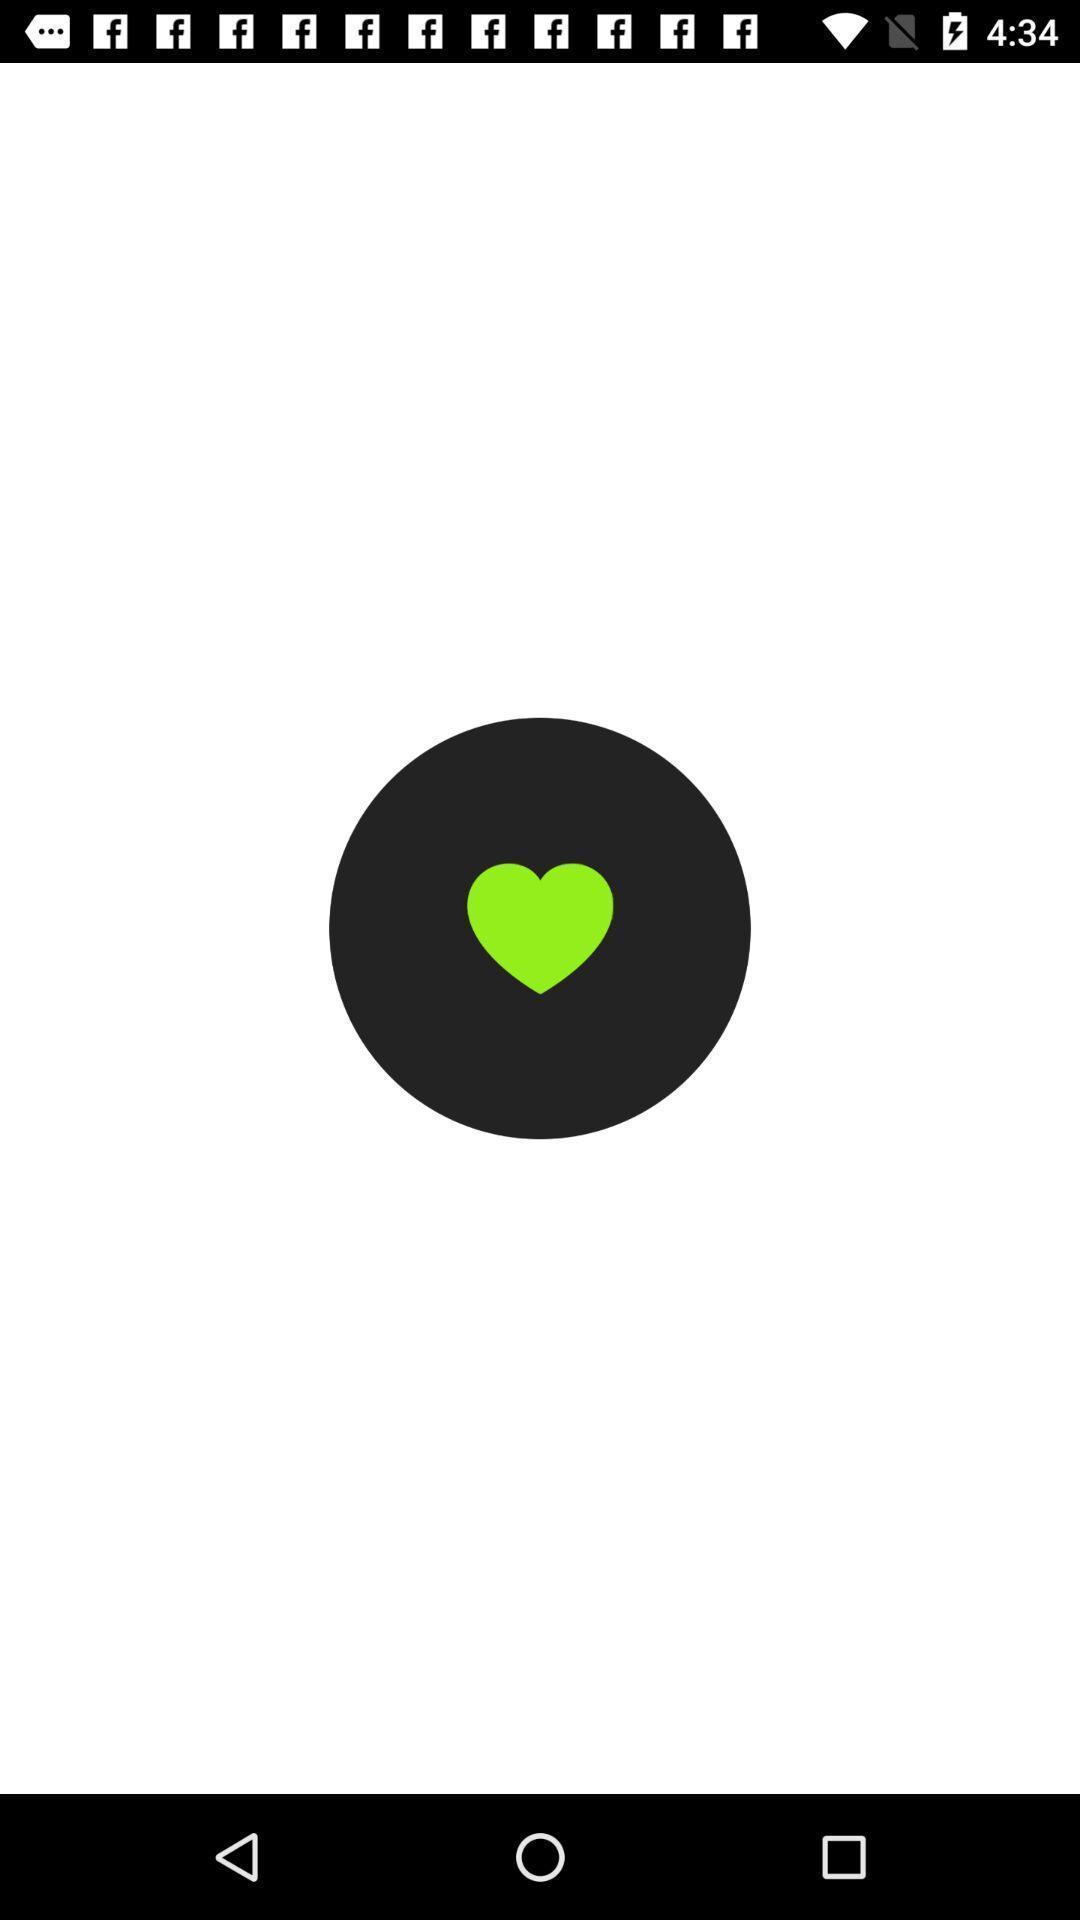Tell me what you see in this picture. Page displaying with a heart emoji. 